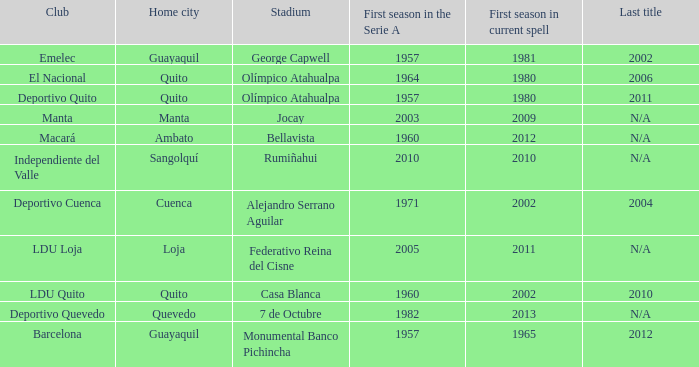Name the last title for cuenca 2004.0. 